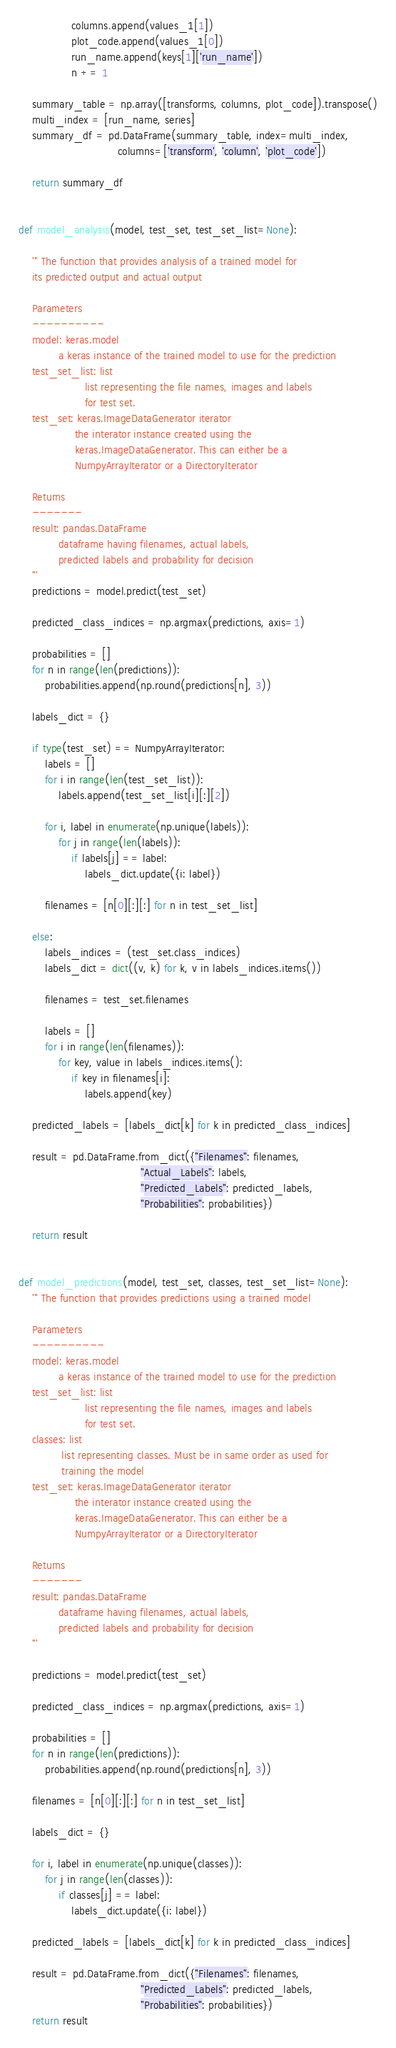Convert code to text. <code><loc_0><loc_0><loc_500><loc_500><_Python_>                columns.append(values_1[1])
                plot_code.append(values_1[0])
                run_name.append(keys[1]['run_name'])
                n += 1

    summary_table = np.array([transforms, columns, plot_code]).transpose()
    multi_index = [run_name, series]
    summary_df = pd.DataFrame(summary_table, index=multi_index,
                              columns=['transform', 'column', 'plot_code'])

    return summary_df


def model_analysis(model, test_set, test_set_list=None):

    ''' The function that provides analysis of a trained model for
    its predicted output and actual output

    Parameters
    ----------
    model: keras.model
            a keras instance of the trained model to use for the prediction
    test_set_list: list
                    list representing the file names, images and labels
                    for test set.
    test_set: keras.ImageDataGenerator iterator
                 the interator instance created using the
                 keras.ImageDataGenerator. This can either be a
                 NumpyArrayIterator or a DirectoryIterator

    Returns
    -------
    result: pandas.DataFrame
            dataframe having filenames, actual labels,
            predicted labels and probability for decision
    '''
    predictions = model.predict(test_set)

    predicted_class_indices = np.argmax(predictions, axis=1)

    probabilities = []
    for n in range(len(predictions)):
        probabilities.append(np.round(predictions[n], 3))

    labels_dict = {}

    if type(test_set) == NumpyArrayIterator:
        labels = []
        for i in range(len(test_set_list)):
            labels.append(test_set_list[i][:][2])

        for i, label in enumerate(np.unique(labels)):
            for j in range(len(labels)):
                if labels[j] == label:
                    labels_dict.update({i: label})

        filenames = [n[0][:][:] for n in test_set_list]

    else:
        labels_indices = (test_set.class_indices)
        labels_dict = dict((v, k) for k, v in labels_indices.items())

        filenames = test_set.filenames

        labels = []
        for i in range(len(filenames)):
            for key, value in labels_indices.items():
                if key in filenames[i]:
                    labels.append(key)

    predicted_labels = [labels_dict[k] for k in predicted_class_indices]

    result = pd.DataFrame.from_dict({"Filenames": filenames,
                                     "Actual_Labels": labels,
                                     "Predicted_Labels": predicted_labels,
                                     "Probabilities": probabilities})

    return result


def model_predictions(model, test_set, classes, test_set_list=None):
    ''' The function that provides predictions using a trained model

    Parameters
    ----------
    model: keras.model
            a keras instance of the trained model to use for the prediction
    test_set_list: list
                    list representing the file names, images and labels
                    for test set.
    classes: list
             list representing classes. Must be in same order as used for
             training the model
    test_set: keras.ImageDataGenerator iterator
                 the interator instance created using the
                 keras.ImageDataGenerator. This can either be a
                 NumpyArrayIterator or a DirectoryIterator

    Returns
    -------
    result: pandas.DataFrame
            dataframe having filenames, actual labels,
            predicted labels and probability for decision
    '''

    predictions = model.predict(test_set)

    predicted_class_indices = np.argmax(predictions, axis=1)

    probabilities = []
    for n in range(len(predictions)):
        probabilities.append(np.round(predictions[n], 3))

    filenames = [n[0][:][:] for n in test_set_list]

    labels_dict = {}

    for i, label in enumerate(np.unique(classes)):
        for j in range(len(classes)):
            if classes[j] == label:
                labels_dict.update({i: label})

    predicted_labels = [labels_dict[k] for k in predicted_class_indices]

    result = pd.DataFrame.from_dict({"Filenames": filenames,
                                     "Predicted_Labels": predicted_labels,
                                     "Probabilities": probabilities})
    return result
</code> 